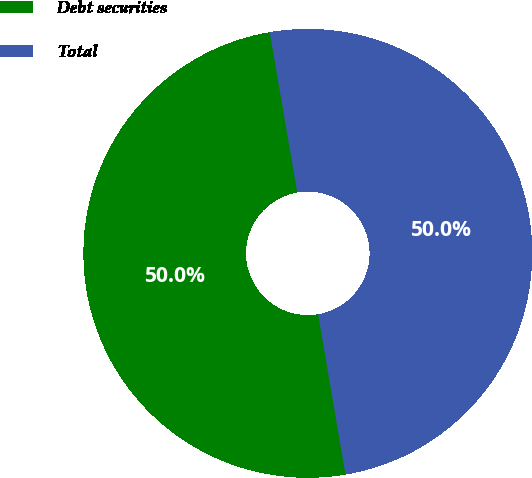Convert chart to OTSL. <chart><loc_0><loc_0><loc_500><loc_500><pie_chart><fcel>Debt securities<fcel>Total<nl><fcel>49.98%<fcel>50.02%<nl></chart> 